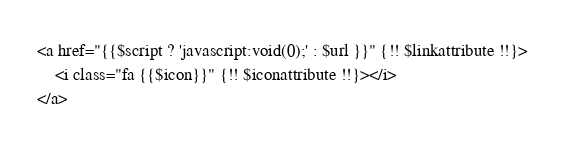Convert code to text. <code><loc_0><loc_0><loc_500><loc_500><_PHP_><a href="{{$script ? 'javascript:void(0);' : $url }}" {!! $linkattribute !!}>
    <i class="fa {{$icon}}" {!! $iconattribute !!}></i>
</a></code> 